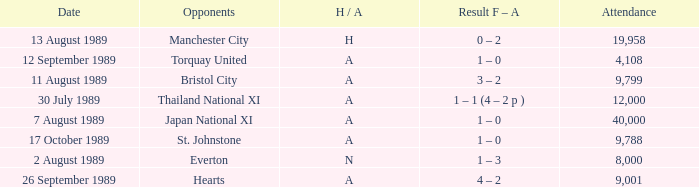How many people attended the match when Manchester United played against the Hearts? 9001.0. 